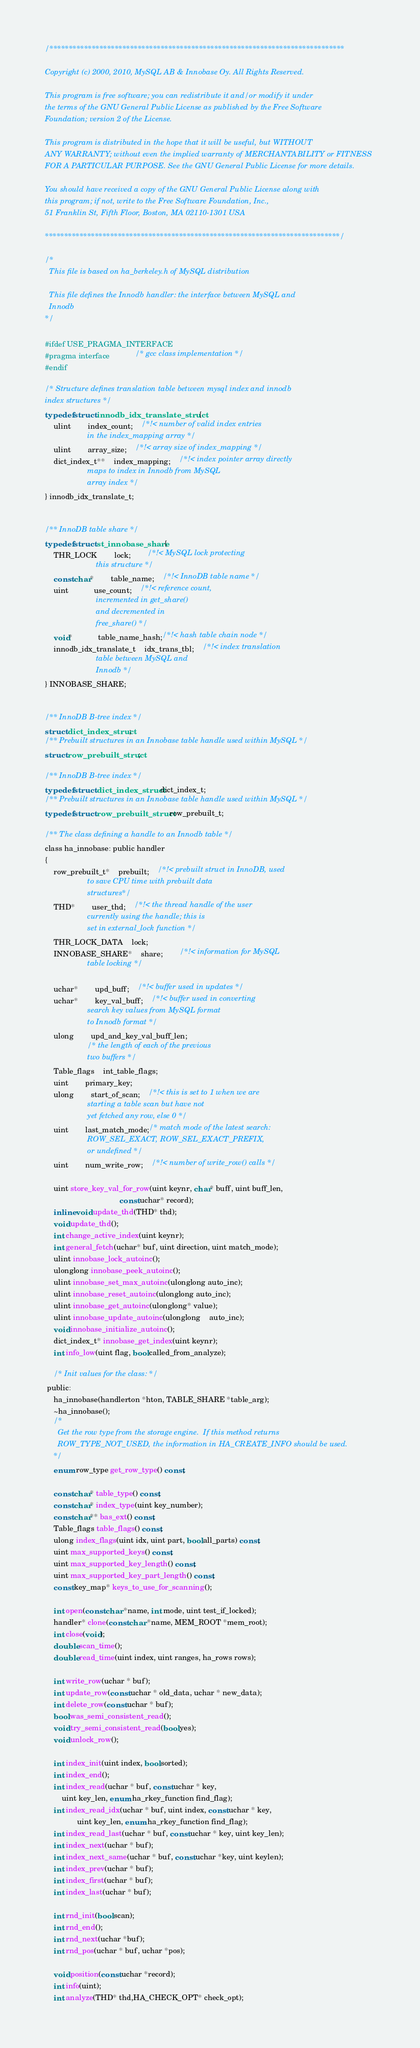Convert code to text. <code><loc_0><loc_0><loc_500><loc_500><_C_>/*****************************************************************************

Copyright (c) 2000, 2010, MySQL AB & Innobase Oy. All Rights Reserved.

This program is free software; you can redistribute it and/or modify it under
the terms of the GNU General Public License as published by the Free Software
Foundation; version 2 of the License.

This program is distributed in the hope that it will be useful, but WITHOUT
ANY WARRANTY; without even the implied warranty of MERCHANTABILITY or FITNESS
FOR A PARTICULAR PURPOSE. See the GNU General Public License for more details.

You should have received a copy of the GNU General Public License along with
this program; if not, write to the Free Software Foundation, Inc., 
51 Franklin St, Fifth Floor, Boston, MA 02110-1301 USA

*****************************************************************************/

/*
  This file is based on ha_berkeley.h of MySQL distribution

  This file defines the Innodb handler: the interface between MySQL and
  Innodb
*/

#ifdef USE_PRAGMA_INTERFACE
#pragma interface			/* gcc class implementation */
#endif

/* Structure defines translation table between mysql index and innodb
index structures */
typedef struct innodb_idx_translate_struct {
	ulint		index_count;	/*!< number of valid index entries
					in the index_mapping array */
	ulint		array_size;	/*!< array size of index_mapping */
	dict_index_t**	index_mapping;	/*!< index pointer array directly
					maps to index in Innodb from MySQL
					array index */
} innodb_idx_translate_t;


/** InnoDB table share */
typedef struct st_innobase_share {
	THR_LOCK		lock;		/*!< MySQL lock protecting
						this structure */
	const char*		table_name;	/*!< InnoDB table name */
	uint			use_count;	/*!< reference count,
						incremented in get_share()
						and decremented in
						free_share() */
	void*			table_name_hash;/*!< hash table chain node */
	innodb_idx_translate_t	idx_trans_tbl;	/*!< index translation
						table between MySQL and
						Innodb */
} INNOBASE_SHARE;


/** InnoDB B-tree index */
struct dict_index_struct;
/** Prebuilt structures in an Innobase table handle used within MySQL */
struct row_prebuilt_struct;

/** InnoDB B-tree index */
typedef struct dict_index_struct dict_index_t;
/** Prebuilt structures in an Innobase table handle used within MySQL */
typedef struct row_prebuilt_struct row_prebuilt_t;

/** The class defining a handle to an Innodb table */
class ha_innobase: public handler
{
	row_prebuilt_t*	prebuilt;	/*!< prebuilt struct in InnoDB, used
					to save CPU time with prebuilt data
					structures*/
	THD*		user_thd;	/*!< the thread handle of the user
					currently using the handle; this is
					set in external_lock function */
	THR_LOCK_DATA	lock;
	INNOBASE_SHARE*	share;		/*!< information for MySQL
					table locking */

	uchar*		upd_buff;	/*!< buffer used in updates */
	uchar*		key_val_buff;	/*!< buffer used in converting
					search key values from MySQL format
					to Innodb format */
	ulong		upd_and_key_val_buff_len;
					/* the length of each of the previous
					two buffers */
	Table_flags	int_table_flags;
	uint		primary_key;
	ulong		start_of_scan;	/*!< this is set to 1 when we are
					starting a table scan but have not
					yet fetched any row, else 0 */
	uint		last_match_mode;/* match mode of the latest search:
					ROW_SEL_EXACT, ROW_SEL_EXACT_PREFIX,
					or undefined */
	uint		num_write_row;	/*!< number of write_row() calls */

	uint store_key_val_for_row(uint keynr, char* buff, uint buff_len,
                                   const uchar* record);
	inline void update_thd(THD* thd);
	void update_thd();
	int change_active_index(uint keynr);
	int general_fetch(uchar* buf, uint direction, uint match_mode);
	ulint innobase_lock_autoinc();
	ulonglong innobase_peek_autoinc();
	ulint innobase_set_max_autoinc(ulonglong auto_inc);
	ulint innobase_reset_autoinc(ulonglong auto_inc);
	ulint innobase_get_autoinc(ulonglong* value);
	ulint innobase_update_autoinc(ulonglong	auto_inc);
	void innobase_initialize_autoinc();
	dict_index_t* innobase_get_index(uint keynr);
	int info_low(uint flag, bool called_from_analyze);

	/* Init values for the class: */
 public:
	ha_innobase(handlerton *hton, TABLE_SHARE *table_arg);
	~ha_innobase();
	/*
	  Get the row type from the storage engine.  If this method returns
	  ROW_TYPE_NOT_USED, the information in HA_CREATE_INFO should be used.
	*/
	enum row_type get_row_type() const;

	const char* table_type() const;
	const char* index_type(uint key_number);
	const char** bas_ext() const;
	Table_flags table_flags() const;
	ulong index_flags(uint idx, uint part, bool all_parts) const;
	uint max_supported_keys() const;
	uint max_supported_key_length() const;
	uint max_supported_key_part_length() const;
	const key_map* keys_to_use_for_scanning();

	int open(const char *name, int mode, uint test_if_locked);
	handler* clone(const char *name, MEM_ROOT *mem_root);
	int close(void);
	double scan_time();
	double read_time(uint index, uint ranges, ha_rows rows);

	int write_row(uchar * buf);
	int update_row(const uchar * old_data, uchar * new_data);
	int delete_row(const uchar * buf);
	bool was_semi_consistent_read();
	void try_semi_consistent_read(bool yes);
	void unlock_row();

	int index_init(uint index, bool sorted);
	int index_end();
	int index_read(uchar * buf, const uchar * key,
		uint key_len, enum ha_rkey_function find_flag);
	int index_read_idx(uchar * buf, uint index, const uchar * key,
			   uint key_len, enum ha_rkey_function find_flag);
	int index_read_last(uchar * buf, const uchar * key, uint key_len);
	int index_next(uchar * buf);
	int index_next_same(uchar * buf, const uchar *key, uint keylen);
	int index_prev(uchar * buf);
	int index_first(uchar * buf);
	int index_last(uchar * buf);

	int rnd_init(bool scan);
	int rnd_end();
	int rnd_next(uchar *buf);
	int rnd_pos(uchar * buf, uchar *pos);

	void position(const uchar *record);
	int info(uint);
	int analyze(THD* thd,HA_CHECK_OPT* check_opt);</code> 